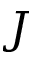<formula> <loc_0><loc_0><loc_500><loc_500>J</formula> 